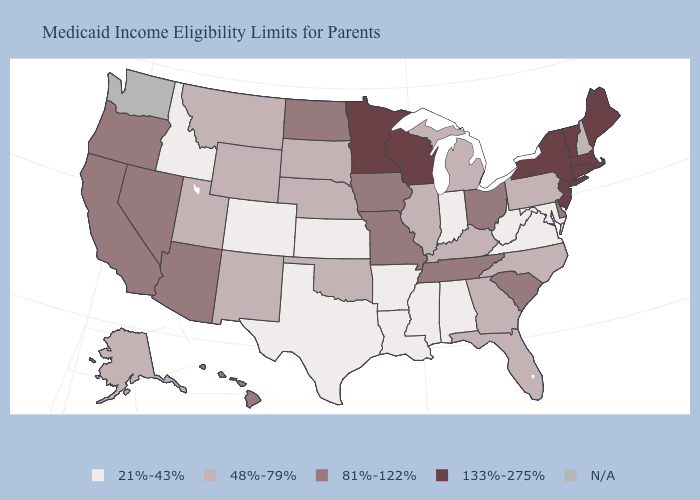What is the value of West Virginia?
Write a very short answer. 21%-43%. What is the highest value in states that border New Hampshire?
Short answer required. 133%-275%. Does Alaska have the highest value in the West?
Give a very brief answer. No. What is the value of Maine?
Short answer required. 133%-275%. What is the highest value in the USA?
Keep it brief. 133%-275%. What is the lowest value in states that border Mississippi?
Write a very short answer. 21%-43%. What is the value of Montana?
Concise answer only. 48%-79%. Name the states that have a value in the range 133%-275%?
Quick response, please. Connecticut, Maine, Massachusetts, Minnesota, New Jersey, New York, Rhode Island, Vermont, Wisconsin. Name the states that have a value in the range 81%-122%?
Answer briefly. Arizona, California, Delaware, Hawaii, Iowa, Missouri, Nevada, North Dakota, Ohio, Oregon, South Carolina, Tennessee. Name the states that have a value in the range 21%-43%?
Concise answer only. Alabama, Arkansas, Colorado, Idaho, Indiana, Kansas, Louisiana, Maryland, Mississippi, Texas, Virginia, West Virginia. What is the highest value in the South ?
Answer briefly. 81%-122%. What is the value of Indiana?
Write a very short answer. 21%-43%. What is the lowest value in states that border West Virginia?
Write a very short answer. 21%-43%. Name the states that have a value in the range 81%-122%?
Concise answer only. Arizona, California, Delaware, Hawaii, Iowa, Missouri, Nevada, North Dakota, Ohio, Oregon, South Carolina, Tennessee. 